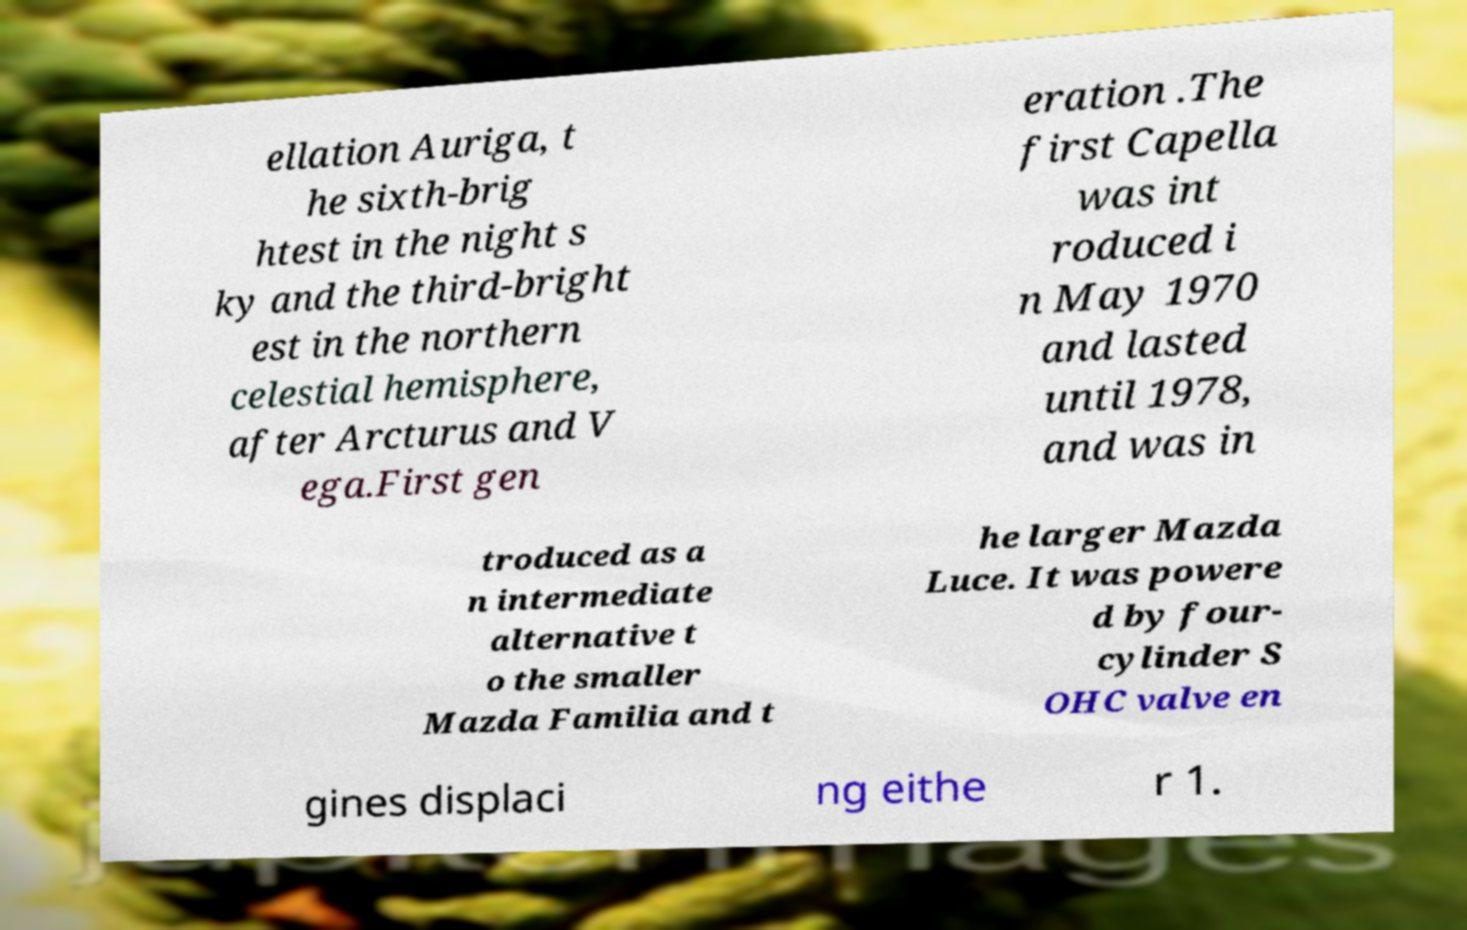What messages or text are displayed in this image? I need them in a readable, typed format. ellation Auriga, t he sixth-brig htest in the night s ky and the third-bright est in the northern celestial hemisphere, after Arcturus and V ega.First gen eration .The first Capella was int roduced i n May 1970 and lasted until 1978, and was in troduced as a n intermediate alternative t o the smaller Mazda Familia and t he larger Mazda Luce. It was powere d by four- cylinder S OHC valve en gines displaci ng eithe r 1. 